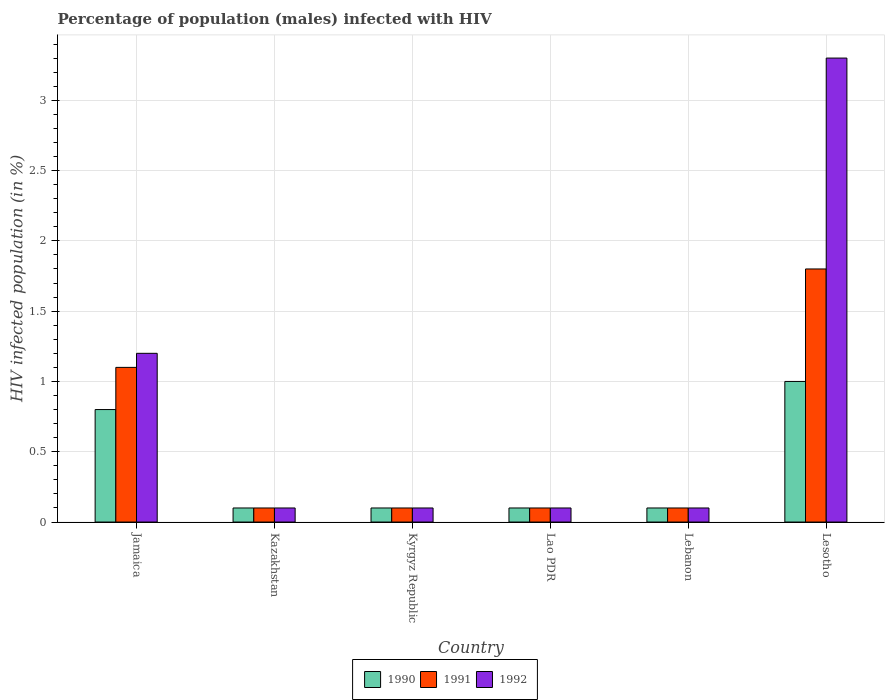Are the number of bars per tick equal to the number of legend labels?
Your answer should be very brief. Yes. How many bars are there on the 4th tick from the left?
Your answer should be compact. 3. How many bars are there on the 6th tick from the right?
Your response must be concise. 3. What is the label of the 1st group of bars from the left?
Give a very brief answer. Jamaica. What is the percentage of HIV infected male population in 1990 in Lesotho?
Your answer should be compact. 1. In which country was the percentage of HIV infected male population in 1990 maximum?
Offer a terse response. Lesotho. In which country was the percentage of HIV infected male population in 1991 minimum?
Your answer should be compact. Kazakhstan. What is the total percentage of HIV infected male population in 1992 in the graph?
Give a very brief answer. 4.9. What is the difference between the percentage of HIV infected male population in 1990 in Kyrgyz Republic and that in Lao PDR?
Provide a short and direct response. 0. What is the difference between the percentage of HIV infected male population in 1990 in Kyrgyz Republic and the percentage of HIV infected male population in 1992 in Lesotho?
Keep it short and to the point. -3.2. What is the average percentage of HIV infected male population in 1992 per country?
Keep it short and to the point. 0.82. What is the difference between the percentage of HIV infected male population of/in 1992 and percentage of HIV infected male population of/in 1991 in Kyrgyz Republic?
Keep it short and to the point. 0. Is the percentage of HIV infected male population in 1990 in Jamaica less than that in Lesotho?
Provide a succinct answer. Yes. What is the difference between the highest and the second highest percentage of HIV infected male population in 1990?
Provide a short and direct response. -0.2. What is the difference between the highest and the lowest percentage of HIV infected male population in 1992?
Provide a succinct answer. 3.2. In how many countries, is the percentage of HIV infected male population in 1991 greater than the average percentage of HIV infected male population in 1991 taken over all countries?
Offer a terse response. 2. Is the sum of the percentage of HIV infected male population in 1991 in Jamaica and Kyrgyz Republic greater than the maximum percentage of HIV infected male population in 1992 across all countries?
Ensure brevity in your answer.  No. How many bars are there?
Provide a succinct answer. 18. How many countries are there in the graph?
Offer a very short reply. 6. What is the difference between two consecutive major ticks on the Y-axis?
Keep it short and to the point. 0.5. Are the values on the major ticks of Y-axis written in scientific E-notation?
Offer a terse response. No. Does the graph contain any zero values?
Provide a succinct answer. No. Does the graph contain grids?
Provide a short and direct response. Yes. Where does the legend appear in the graph?
Keep it short and to the point. Bottom center. What is the title of the graph?
Your answer should be compact. Percentage of population (males) infected with HIV. What is the label or title of the X-axis?
Your response must be concise. Country. What is the label or title of the Y-axis?
Your answer should be compact. HIV infected population (in %). What is the HIV infected population (in %) in 1991 in Kazakhstan?
Ensure brevity in your answer.  0.1. What is the HIV infected population (in %) of 1992 in Kyrgyz Republic?
Your answer should be compact. 0.1. What is the HIV infected population (in %) in 1990 in Lao PDR?
Your answer should be very brief. 0.1. What is the HIV infected population (in %) of 1992 in Lebanon?
Make the answer very short. 0.1. What is the HIV infected population (in %) in 1992 in Lesotho?
Offer a very short reply. 3.3. Across all countries, what is the maximum HIV infected population (in %) of 1990?
Ensure brevity in your answer.  1. Across all countries, what is the minimum HIV infected population (in %) in 1990?
Offer a terse response. 0.1. Across all countries, what is the minimum HIV infected population (in %) of 1992?
Make the answer very short. 0.1. What is the difference between the HIV infected population (in %) in 1992 in Jamaica and that in Lao PDR?
Make the answer very short. 1.1. What is the difference between the HIV infected population (in %) of 1992 in Jamaica and that in Lebanon?
Give a very brief answer. 1.1. What is the difference between the HIV infected population (in %) in 1990 in Jamaica and that in Lesotho?
Keep it short and to the point. -0.2. What is the difference between the HIV infected population (in %) of 1991 in Jamaica and that in Lesotho?
Make the answer very short. -0.7. What is the difference between the HIV infected population (in %) of 1990 in Kazakhstan and that in Kyrgyz Republic?
Your answer should be compact. 0. What is the difference between the HIV infected population (in %) of 1992 in Kazakhstan and that in Kyrgyz Republic?
Your answer should be compact. 0. What is the difference between the HIV infected population (in %) in 1990 in Kazakhstan and that in Lao PDR?
Keep it short and to the point. 0. What is the difference between the HIV infected population (in %) in 1991 in Kazakhstan and that in Lebanon?
Your answer should be very brief. 0. What is the difference between the HIV infected population (in %) in 1992 in Kazakhstan and that in Lebanon?
Ensure brevity in your answer.  0. What is the difference between the HIV infected population (in %) in 1990 in Kazakhstan and that in Lesotho?
Give a very brief answer. -0.9. What is the difference between the HIV infected population (in %) in 1990 in Kyrgyz Republic and that in Lao PDR?
Give a very brief answer. 0. What is the difference between the HIV infected population (in %) of 1991 in Kyrgyz Republic and that in Lao PDR?
Make the answer very short. 0. What is the difference between the HIV infected population (in %) of 1990 in Kyrgyz Republic and that in Lebanon?
Ensure brevity in your answer.  0. What is the difference between the HIV infected population (in %) of 1990 in Kyrgyz Republic and that in Lesotho?
Your answer should be very brief. -0.9. What is the difference between the HIV infected population (in %) in 1991 in Kyrgyz Republic and that in Lesotho?
Make the answer very short. -1.7. What is the difference between the HIV infected population (in %) of 1990 in Lao PDR and that in Lebanon?
Make the answer very short. 0. What is the difference between the HIV infected population (in %) in 1991 in Lao PDR and that in Lebanon?
Offer a terse response. 0. What is the difference between the HIV infected population (in %) of 1991 in Lao PDR and that in Lesotho?
Give a very brief answer. -1.7. What is the difference between the HIV infected population (in %) in 1992 in Lebanon and that in Lesotho?
Your answer should be very brief. -3.2. What is the difference between the HIV infected population (in %) of 1991 in Jamaica and the HIV infected population (in %) of 1992 in Kyrgyz Republic?
Provide a succinct answer. 1. What is the difference between the HIV infected population (in %) of 1991 in Jamaica and the HIV infected population (in %) of 1992 in Lao PDR?
Your answer should be compact. 1. What is the difference between the HIV infected population (in %) of 1990 in Jamaica and the HIV infected population (in %) of 1991 in Lebanon?
Make the answer very short. 0.7. What is the difference between the HIV infected population (in %) in 1991 in Jamaica and the HIV infected population (in %) in 1992 in Lesotho?
Offer a very short reply. -2.2. What is the difference between the HIV infected population (in %) of 1990 in Kazakhstan and the HIV infected population (in %) of 1992 in Kyrgyz Republic?
Your response must be concise. 0. What is the difference between the HIV infected population (in %) in 1990 in Kazakhstan and the HIV infected population (in %) in 1991 in Lao PDR?
Give a very brief answer. 0. What is the difference between the HIV infected population (in %) of 1990 in Kazakhstan and the HIV infected population (in %) of 1992 in Lao PDR?
Your answer should be compact. 0. What is the difference between the HIV infected population (in %) in 1991 in Kazakhstan and the HIV infected population (in %) in 1992 in Lao PDR?
Make the answer very short. 0. What is the difference between the HIV infected population (in %) in 1990 in Kazakhstan and the HIV infected population (in %) in 1991 in Lebanon?
Ensure brevity in your answer.  0. What is the difference between the HIV infected population (in %) of 1990 in Kazakhstan and the HIV infected population (in %) of 1992 in Lebanon?
Provide a succinct answer. 0. What is the difference between the HIV infected population (in %) of 1991 in Kazakhstan and the HIV infected population (in %) of 1992 in Lebanon?
Your answer should be very brief. 0. What is the difference between the HIV infected population (in %) of 1990 in Kazakhstan and the HIV infected population (in %) of 1991 in Lesotho?
Your answer should be very brief. -1.7. What is the difference between the HIV infected population (in %) in 1991 in Kazakhstan and the HIV infected population (in %) in 1992 in Lesotho?
Your answer should be compact. -3.2. What is the difference between the HIV infected population (in %) in 1990 in Kyrgyz Republic and the HIV infected population (in %) in 1991 in Lao PDR?
Offer a very short reply. 0. What is the difference between the HIV infected population (in %) of 1990 in Kyrgyz Republic and the HIV infected population (in %) of 1992 in Lao PDR?
Give a very brief answer. 0. What is the difference between the HIV infected population (in %) in 1990 in Kyrgyz Republic and the HIV infected population (in %) in 1991 in Lebanon?
Offer a very short reply. 0. What is the difference between the HIV infected population (in %) of 1990 in Kyrgyz Republic and the HIV infected population (in %) of 1992 in Lebanon?
Make the answer very short. 0. What is the difference between the HIV infected population (in %) in 1991 in Kyrgyz Republic and the HIV infected population (in %) in 1992 in Lebanon?
Provide a succinct answer. 0. What is the difference between the HIV infected population (in %) of 1990 in Kyrgyz Republic and the HIV infected population (in %) of 1992 in Lesotho?
Make the answer very short. -3.2. What is the difference between the HIV infected population (in %) of 1990 in Lao PDR and the HIV infected population (in %) of 1992 in Lebanon?
Ensure brevity in your answer.  0. What is the difference between the HIV infected population (in %) of 1991 in Lao PDR and the HIV infected population (in %) of 1992 in Lebanon?
Provide a succinct answer. 0. What is the difference between the HIV infected population (in %) in 1990 in Lebanon and the HIV infected population (in %) in 1992 in Lesotho?
Your answer should be compact. -3.2. What is the average HIV infected population (in %) in 1990 per country?
Your response must be concise. 0.37. What is the average HIV infected population (in %) of 1991 per country?
Provide a succinct answer. 0.55. What is the average HIV infected population (in %) of 1992 per country?
Your response must be concise. 0.82. What is the difference between the HIV infected population (in %) of 1990 and HIV infected population (in %) of 1991 in Lao PDR?
Offer a very short reply. 0. What is the difference between the HIV infected population (in %) in 1990 and HIV infected population (in %) in 1992 in Lao PDR?
Provide a succinct answer. 0. What is the difference between the HIV infected population (in %) of 1991 and HIV infected population (in %) of 1992 in Lao PDR?
Ensure brevity in your answer.  0. What is the difference between the HIV infected population (in %) of 1990 and HIV infected population (in %) of 1991 in Lebanon?
Keep it short and to the point. 0. What is the difference between the HIV infected population (in %) of 1991 and HIV infected population (in %) of 1992 in Lebanon?
Make the answer very short. 0. What is the difference between the HIV infected population (in %) of 1990 and HIV infected population (in %) of 1991 in Lesotho?
Offer a terse response. -0.8. What is the difference between the HIV infected population (in %) in 1990 and HIV infected population (in %) in 1992 in Lesotho?
Your answer should be compact. -2.3. What is the difference between the HIV infected population (in %) in 1991 and HIV infected population (in %) in 1992 in Lesotho?
Your answer should be compact. -1.5. What is the ratio of the HIV infected population (in %) of 1990 in Jamaica to that in Kazakhstan?
Offer a very short reply. 8. What is the ratio of the HIV infected population (in %) in 1991 in Jamaica to that in Kyrgyz Republic?
Your response must be concise. 11. What is the ratio of the HIV infected population (in %) in 1992 in Jamaica to that in Lebanon?
Your answer should be compact. 12. What is the ratio of the HIV infected population (in %) of 1991 in Jamaica to that in Lesotho?
Make the answer very short. 0.61. What is the ratio of the HIV infected population (in %) of 1992 in Jamaica to that in Lesotho?
Offer a very short reply. 0.36. What is the ratio of the HIV infected population (in %) in 1991 in Kazakhstan to that in Kyrgyz Republic?
Your response must be concise. 1. What is the ratio of the HIV infected population (in %) of 1991 in Kazakhstan to that in Lao PDR?
Your answer should be very brief. 1. What is the ratio of the HIV infected population (in %) of 1990 in Kazakhstan to that in Lebanon?
Offer a very short reply. 1. What is the ratio of the HIV infected population (in %) of 1992 in Kazakhstan to that in Lebanon?
Your response must be concise. 1. What is the ratio of the HIV infected population (in %) of 1991 in Kazakhstan to that in Lesotho?
Make the answer very short. 0.06. What is the ratio of the HIV infected population (in %) of 1992 in Kazakhstan to that in Lesotho?
Offer a very short reply. 0.03. What is the ratio of the HIV infected population (in %) in 1990 in Kyrgyz Republic to that in Lao PDR?
Provide a short and direct response. 1. What is the ratio of the HIV infected population (in %) of 1992 in Kyrgyz Republic to that in Lao PDR?
Give a very brief answer. 1. What is the ratio of the HIV infected population (in %) of 1991 in Kyrgyz Republic to that in Lebanon?
Your answer should be very brief. 1. What is the ratio of the HIV infected population (in %) of 1991 in Kyrgyz Republic to that in Lesotho?
Your answer should be very brief. 0.06. What is the ratio of the HIV infected population (in %) in 1992 in Kyrgyz Republic to that in Lesotho?
Offer a terse response. 0.03. What is the ratio of the HIV infected population (in %) in 1990 in Lao PDR to that in Lebanon?
Provide a short and direct response. 1. What is the ratio of the HIV infected population (in %) of 1992 in Lao PDR to that in Lebanon?
Your answer should be compact. 1. What is the ratio of the HIV infected population (in %) in 1990 in Lao PDR to that in Lesotho?
Give a very brief answer. 0.1. What is the ratio of the HIV infected population (in %) in 1991 in Lao PDR to that in Lesotho?
Make the answer very short. 0.06. What is the ratio of the HIV infected population (in %) in 1992 in Lao PDR to that in Lesotho?
Your response must be concise. 0.03. What is the ratio of the HIV infected population (in %) of 1990 in Lebanon to that in Lesotho?
Keep it short and to the point. 0.1. What is the ratio of the HIV infected population (in %) in 1991 in Lebanon to that in Lesotho?
Keep it short and to the point. 0.06. What is the ratio of the HIV infected population (in %) of 1992 in Lebanon to that in Lesotho?
Your response must be concise. 0.03. What is the difference between the highest and the second highest HIV infected population (in %) of 1990?
Give a very brief answer. 0.2. What is the difference between the highest and the second highest HIV infected population (in %) in 1991?
Provide a succinct answer. 0.7. What is the difference between the highest and the lowest HIV infected population (in %) in 1991?
Keep it short and to the point. 1.7. 